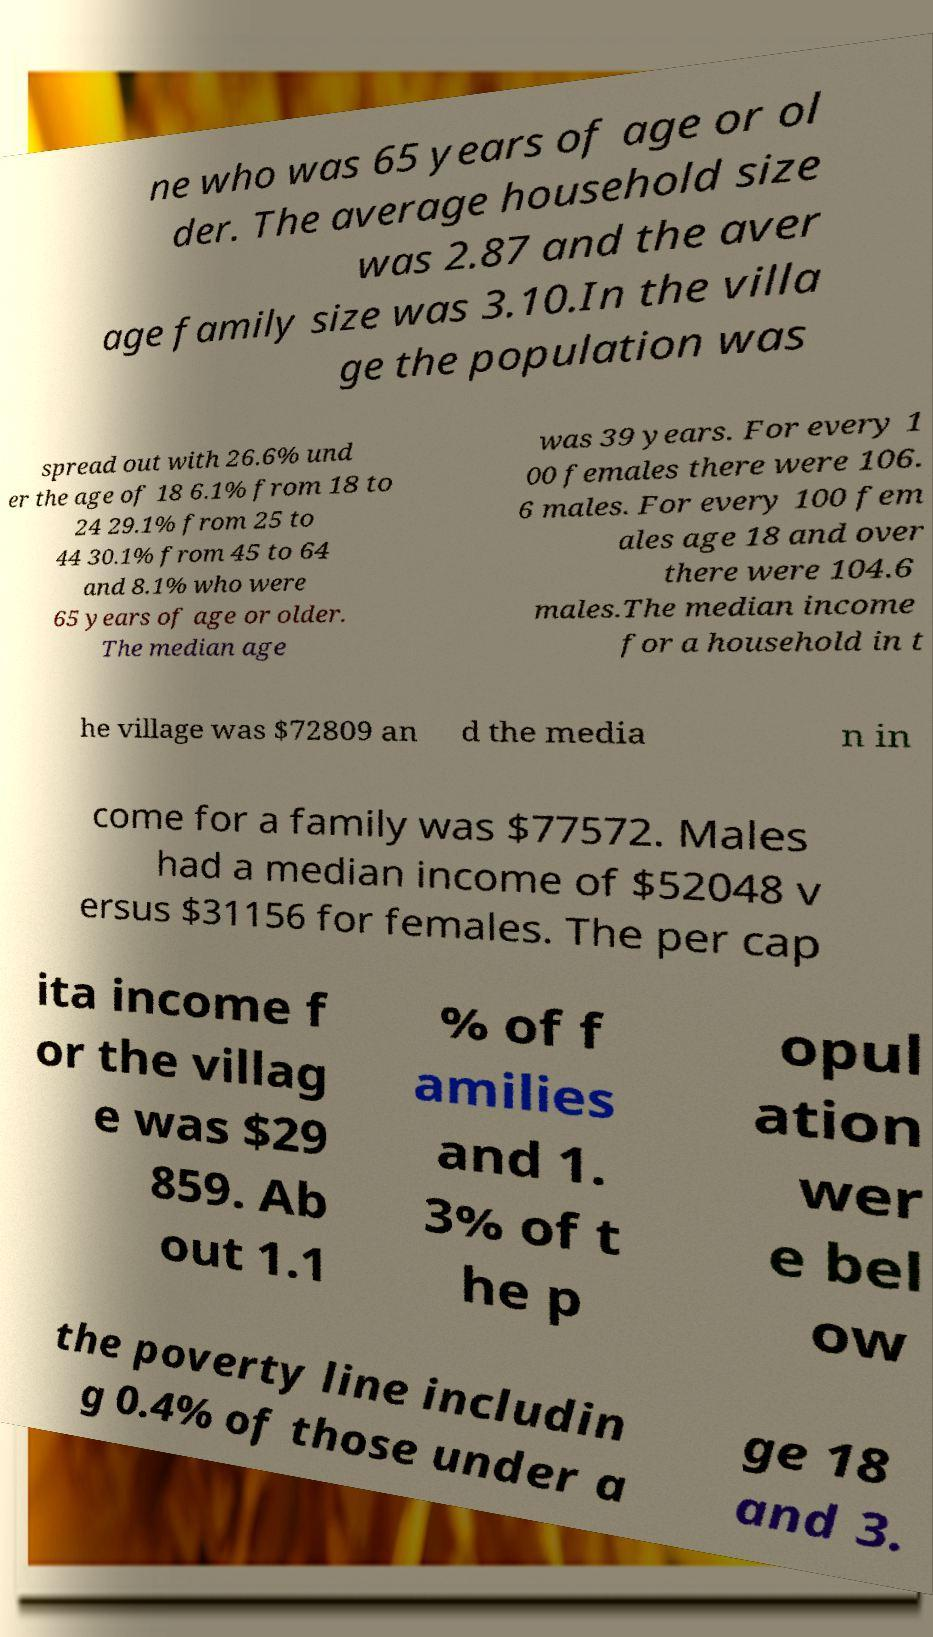Can you accurately transcribe the text from the provided image for me? ne who was 65 years of age or ol der. The average household size was 2.87 and the aver age family size was 3.10.In the villa ge the population was spread out with 26.6% und er the age of 18 6.1% from 18 to 24 29.1% from 25 to 44 30.1% from 45 to 64 and 8.1% who were 65 years of age or older. The median age was 39 years. For every 1 00 females there were 106. 6 males. For every 100 fem ales age 18 and over there were 104.6 males.The median income for a household in t he village was $72809 an d the media n in come for a family was $77572. Males had a median income of $52048 v ersus $31156 for females. The per cap ita income f or the villag e was $29 859. Ab out 1.1 % of f amilies and 1. 3% of t he p opul ation wer e bel ow the poverty line includin g 0.4% of those under a ge 18 and 3. 